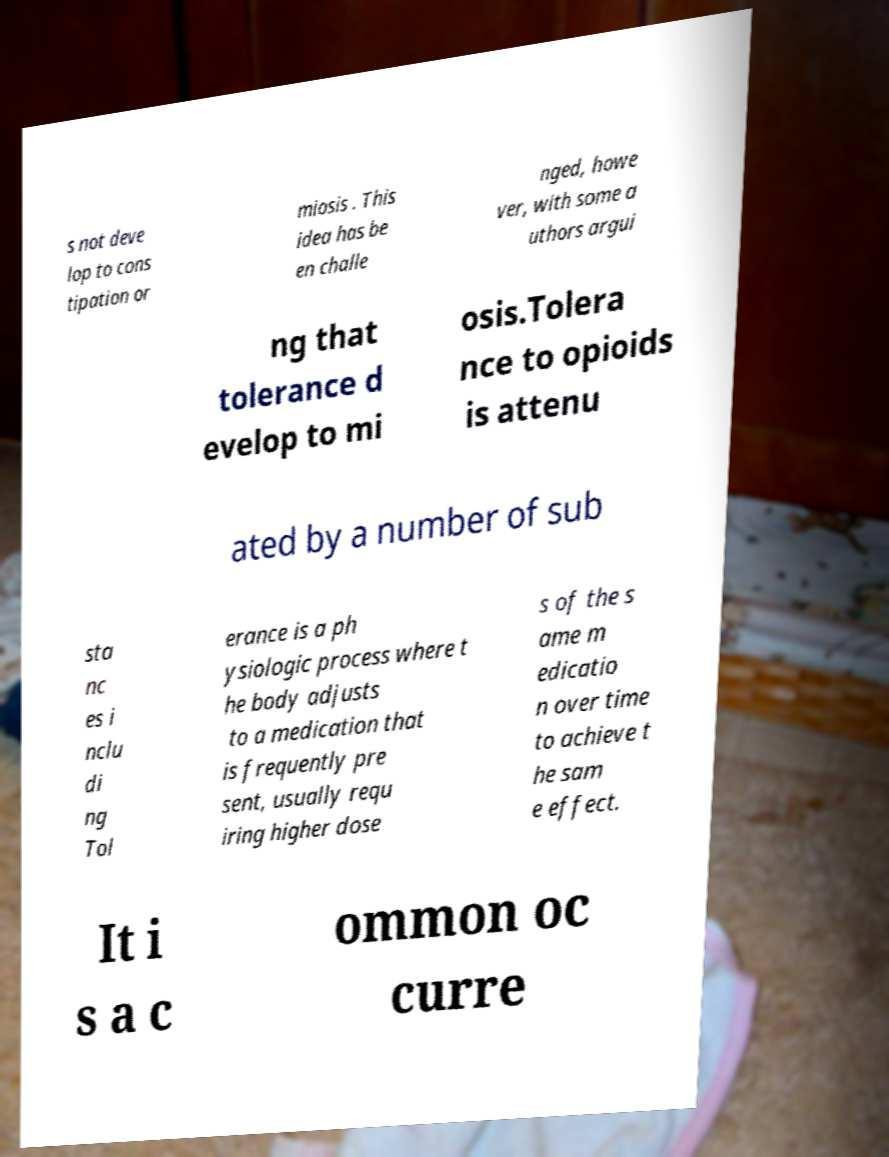Please identify and transcribe the text found in this image. s not deve lop to cons tipation or miosis . This idea has be en challe nged, howe ver, with some a uthors argui ng that tolerance d evelop to mi osis.Tolera nce to opioids is attenu ated by a number of sub sta nc es i nclu di ng Tol erance is a ph ysiologic process where t he body adjusts to a medication that is frequently pre sent, usually requ iring higher dose s of the s ame m edicatio n over time to achieve t he sam e effect. It i s a c ommon oc curre 